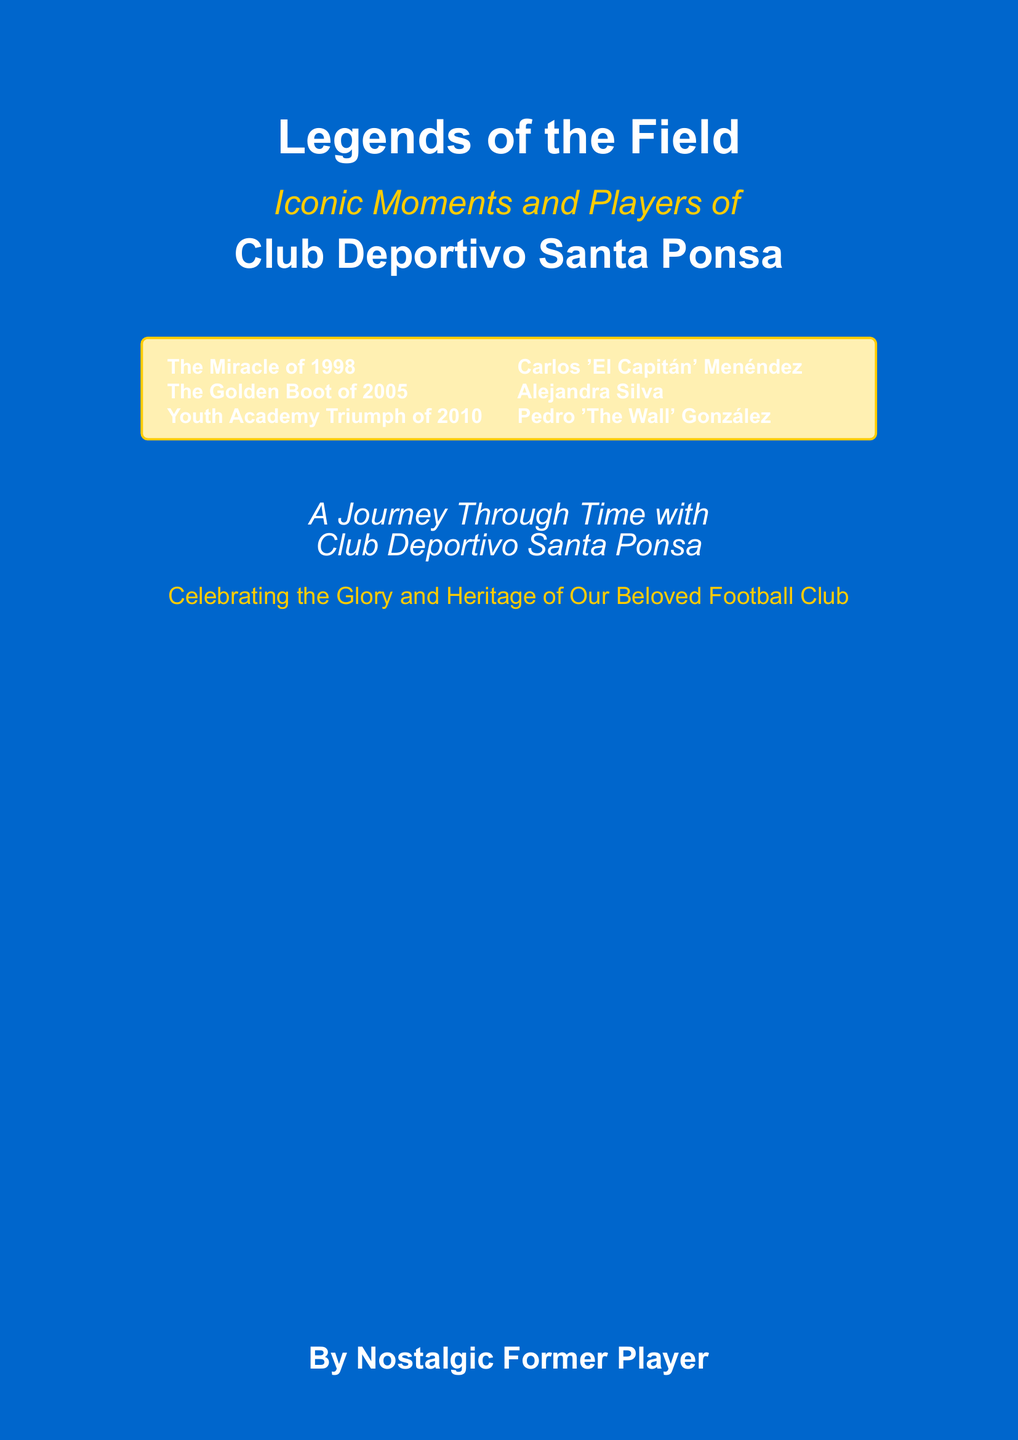What is the title of the book? The title of the book is the main heading prominently displayed on the cover.
Answer: Legends of the Field What year is associated with "The Miracle"? This moment is highlighted prominently in the first section of the tcolorbox.
Answer: 1998 Who is referred to as "El Capitán"? This name is listed among the notable players in the document.
Answer: Carlos Menéndez What significant event is highlighted in 2005? This event is emphasized in the tcolorbox along with the other notable moments.
Answer: The Golden Boot How many iconic moments are mentioned on the cover? The cover contains a list of three notable moments in the tcolorbox.
Answer: 3 What is the color of the cover? The color is specified at the beginning of the document for the background.
Answer: Blue What is the subtitle of the book? The subtitle complements the main title and is visually smaller than the title.
Answer: Iconic Moments and Players of Who is the author of the book? The author's name is displayed at the bottom of the cover.
Answer: Nostalgic Former Player In what year was the Youth Academy Triumph? The date of this achievement is presented clearly in the document.
Answer: 2010 